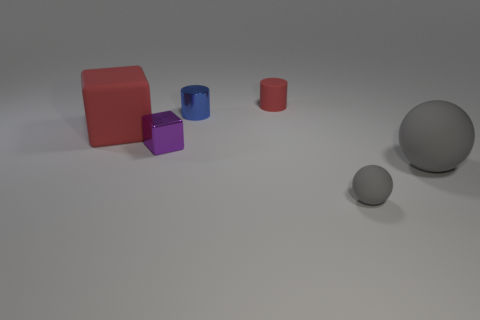There is another small thing that is made of the same material as the purple object; what shape is it?
Your response must be concise. Cylinder. Is the number of tiny gray rubber things that are right of the big ball greater than the number of big gray rubber spheres in front of the tiny gray ball?
Your response must be concise. No. What number of things are small red metal balls or spheres?
Ensure brevity in your answer.  2. How many other objects are there of the same color as the matte block?
Keep it short and to the point. 1. There is a gray matte object that is the same size as the purple metallic thing; what is its shape?
Your answer should be very brief. Sphere. There is a object that is on the left side of the small purple block; what color is it?
Offer a terse response. Red. What number of things are either metallic objects behind the small block or metal things to the left of the blue cylinder?
Your response must be concise. 2. Does the red cylinder have the same size as the blue cylinder?
Offer a very short reply. Yes. What number of spheres are purple things or shiny objects?
Your answer should be compact. 0. How many objects are both on the right side of the metallic cylinder and left of the tiny blue cylinder?
Make the answer very short. 0. 